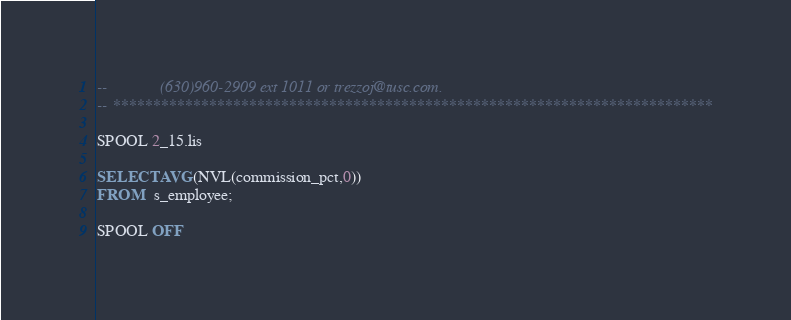<code> <loc_0><loc_0><loc_500><loc_500><_SQL_>--             (630)960-2909 ext 1011 or trezzoj@tusc.com.
-- ***************************************************************************

SPOOL 2_15.lis

SELECT AVG(NVL(commission_pct,0))
FROM   s_employee;

SPOOL OFF
</code> 